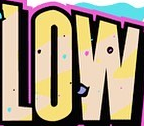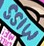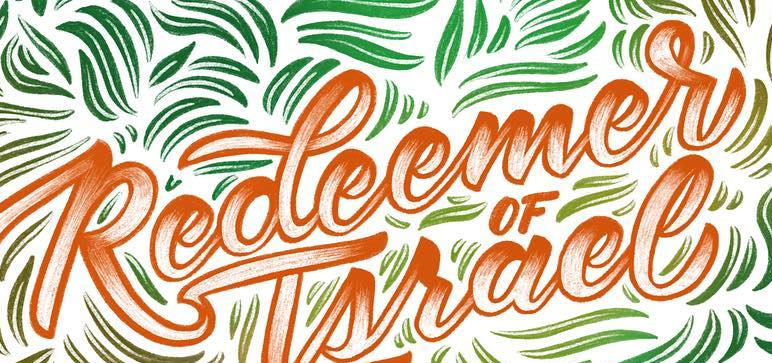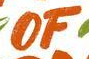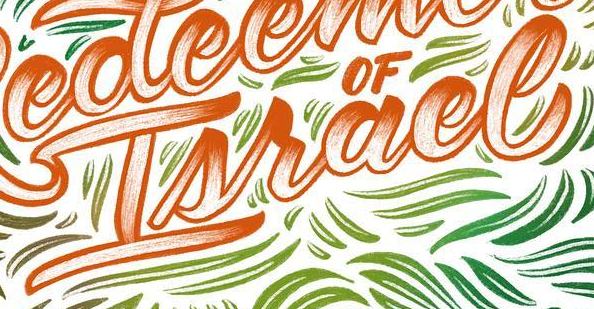What words can you see in these images in sequence, separated by a semicolon? LOW; MISS; Redeemer; OF; Israel 